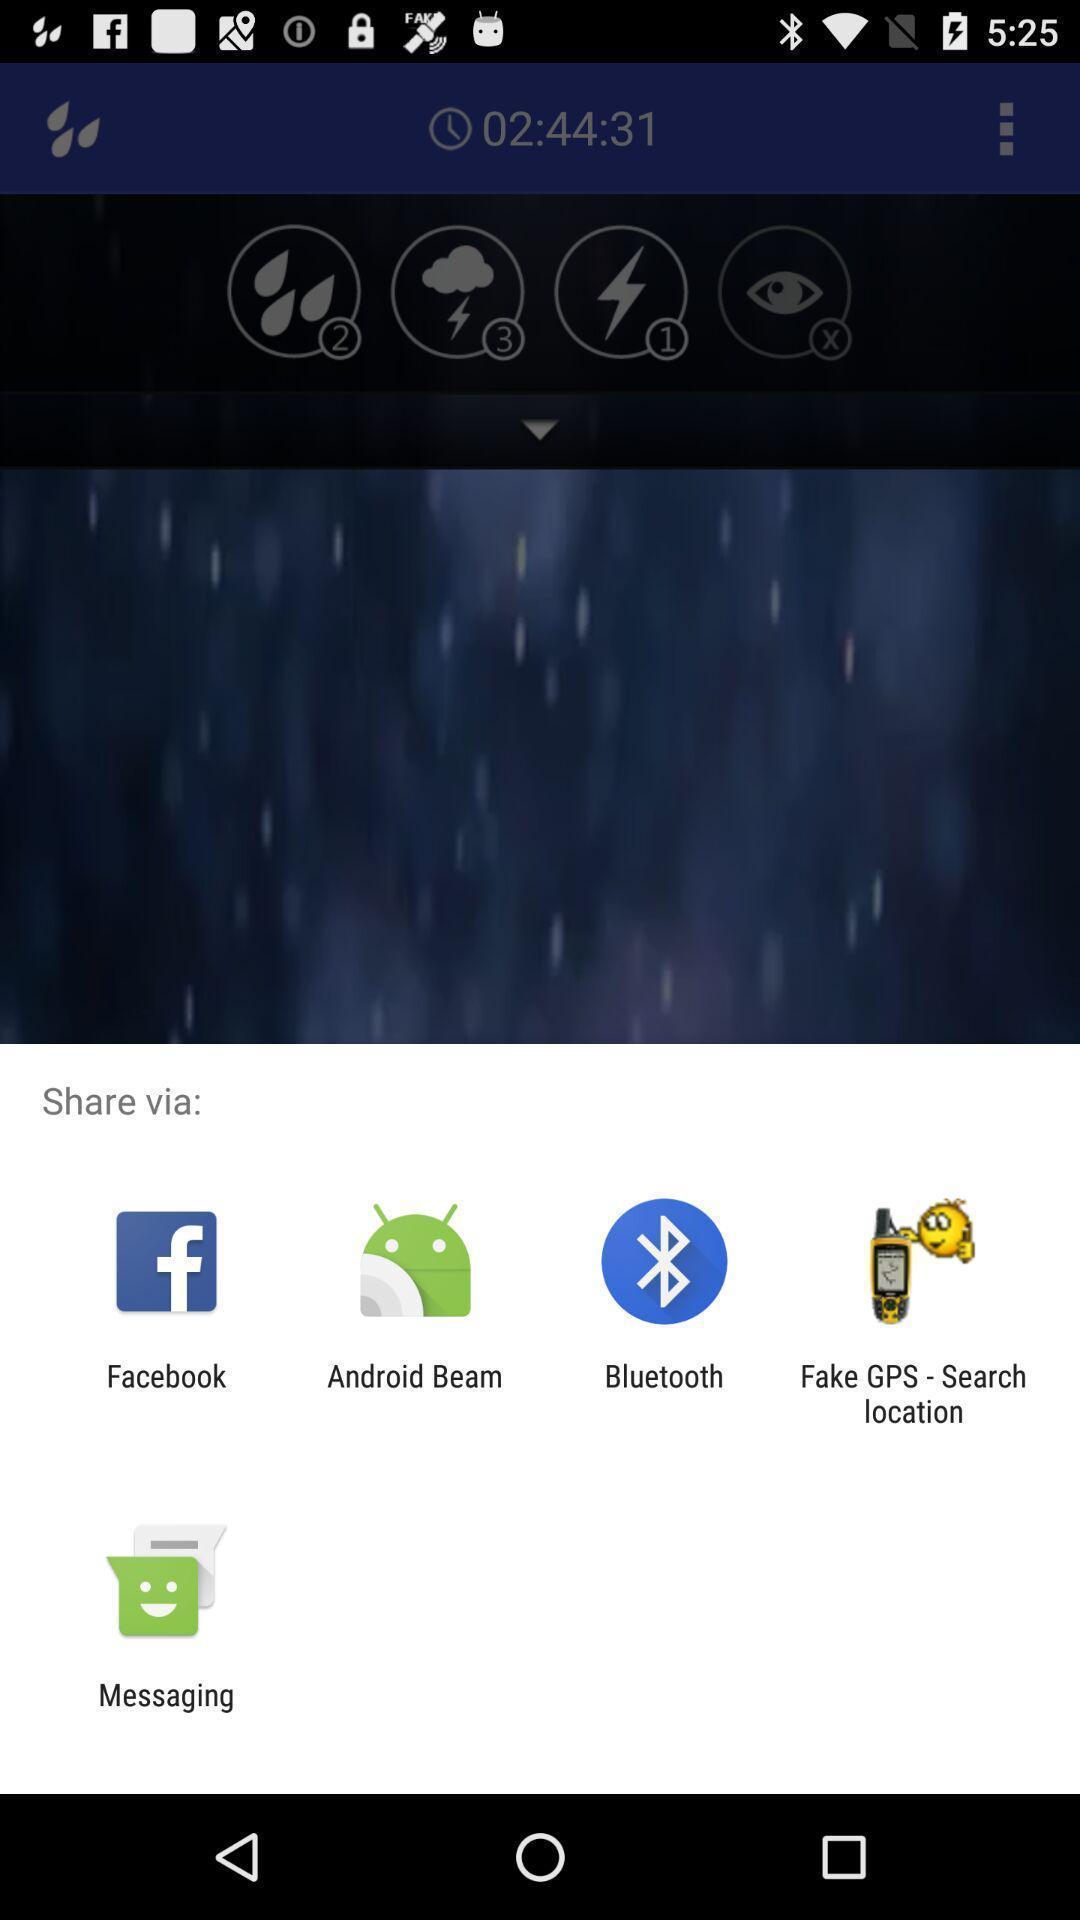Provide a description of this screenshot. Share pop up with list of sharing apps. 